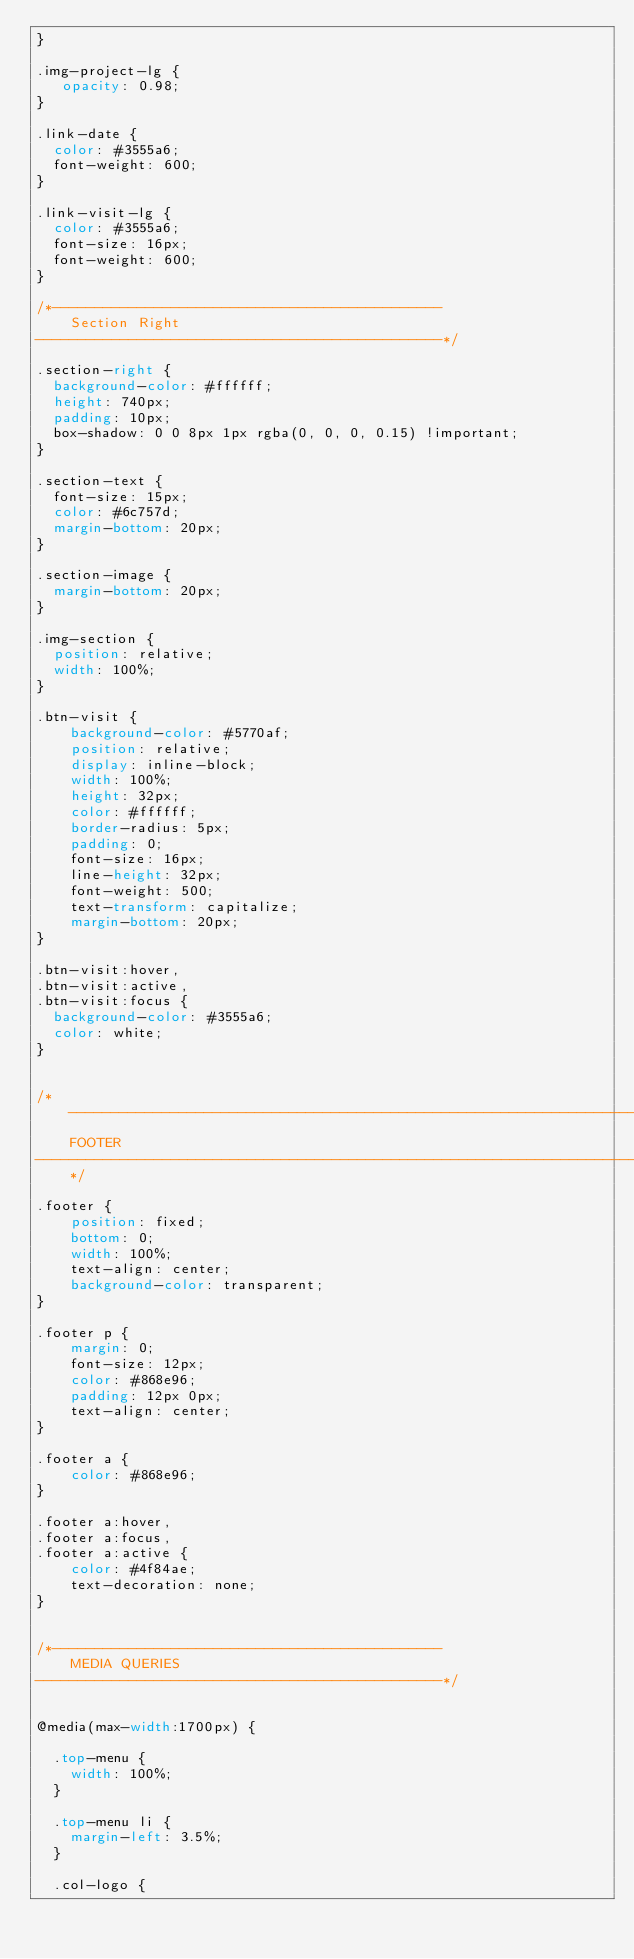Convert code to text. <code><loc_0><loc_0><loc_500><loc_500><_CSS_>}

.img-project-lg {
   opacity: 0.98;
}

.link-date {
  color: #3555a6;
  font-weight: 600;
}

.link-visit-lg {
  color: #3555a6;
  font-size: 16px;
  font-weight: 600;
}

/*----------------------------------------------
    Section Right
------------------------------------------------*/

.section-right {
  background-color: #ffffff;
  height: 740px;
  padding: 10px;
  box-shadow: 0 0 8px 1px rgba(0, 0, 0, 0.15) !important;
}

.section-text {
  font-size: 15px;
  color: #6c757d;
  margin-bottom: 20px;
}

.section-image {
  margin-bottom: 20px;
}

.img-section {
  position: relative;
  width: 100%;
}

.btn-visit {
    background-color: #5770af;
    position: relative;
    display: inline-block;
    width: 100%;
    height: 32px;
    color: #ffffff;
    border-radius: 5px;
    padding: 0;
    font-size: 16px;
    line-height: 32px;
    font-weight: 500;
    text-transform: capitalize;
    margin-bottom: 20px;
}

.btn-visit:hover,
.btn-visit:active,
.btn-visit:focus {
  background-color: #3555a6;
  color: white;
}


/*------------------------------------------------------------------------------
    FOOTER
------------------------------------------------------------------------------*/

.footer {
    position: fixed;
    bottom: 0;
    width: 100%;
    text-align: center;
    background-color: transparent;
}

.footer p {
    margin: 0;
    font-size: 12px;
    color: #868e96;
    padding: 12px 0px;
    text-align: center;
}

.footer a {
    color: #868e96;
}

.footer a:hover,
.footer a:focus,
.footer a:active {
    color: #4f84ae;
    text-decoration: none;
}


/*----------------------------------------------
    MEDIA QUERIES
------------------------------------------------*/


@media(max-width:1700px) {

  .top-menu {
    width: 100%;
  }

  .top-menu li {
    margin-left: 3.5%;
  }

  .col-logo {</code> 